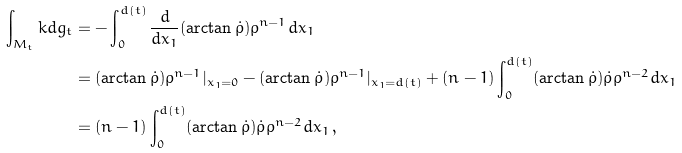Convert formula to latex. <formula><loc_0><loc_0><loc_500><loc_500>\int _ { M _ { t } } k d g _ { t } & = - \int _ { 0 } ^ { d ( t ) } \frac { d } { d x _ { 1 } } ( \arctan \dot { \rho } ) \rho ^ { n - 1 } d x _ { 1 } \\ & = ( \arctan \dot { \rho } ) \rho ^ { n - 1 } | _ { x _ { 1 } = 0 } - ( \arctan \dot { \rho } ) \rho ^ { n - 1 } | _ { x _ { 1 } = d ( t ) } + ( n - 1 ) \int _ { 0 } ^ { d ( t ) } ( \arctan \dot { \rho } ) \dot { \rho } \rho ^ { n - 2 } d x _ { 1 } \\ & = ( n - 1 ) \int _ { 0 } ^ { d ( t ) } ( \arctan \dot { \rho } ) \dot { \rho } \rho ^ { n - 2 } d x _ { 1 } \, ,</formula> 